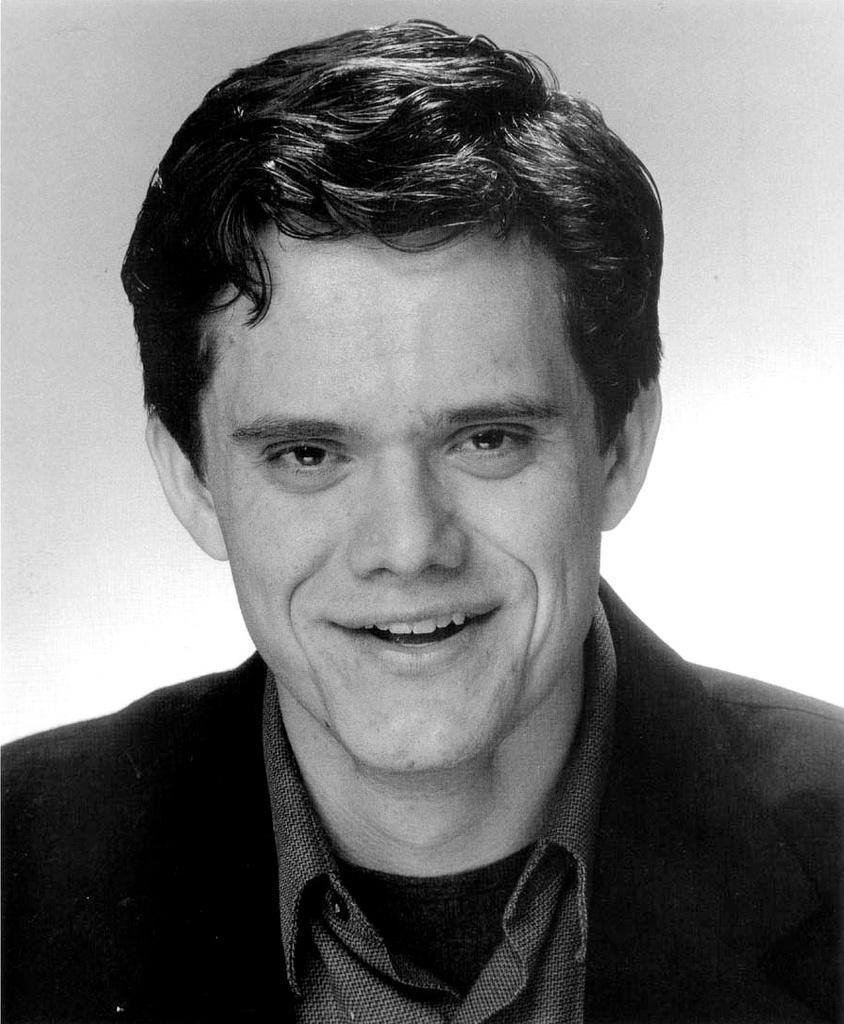Can you describe this image briefly? In this picture there is a man in the center of the image. 